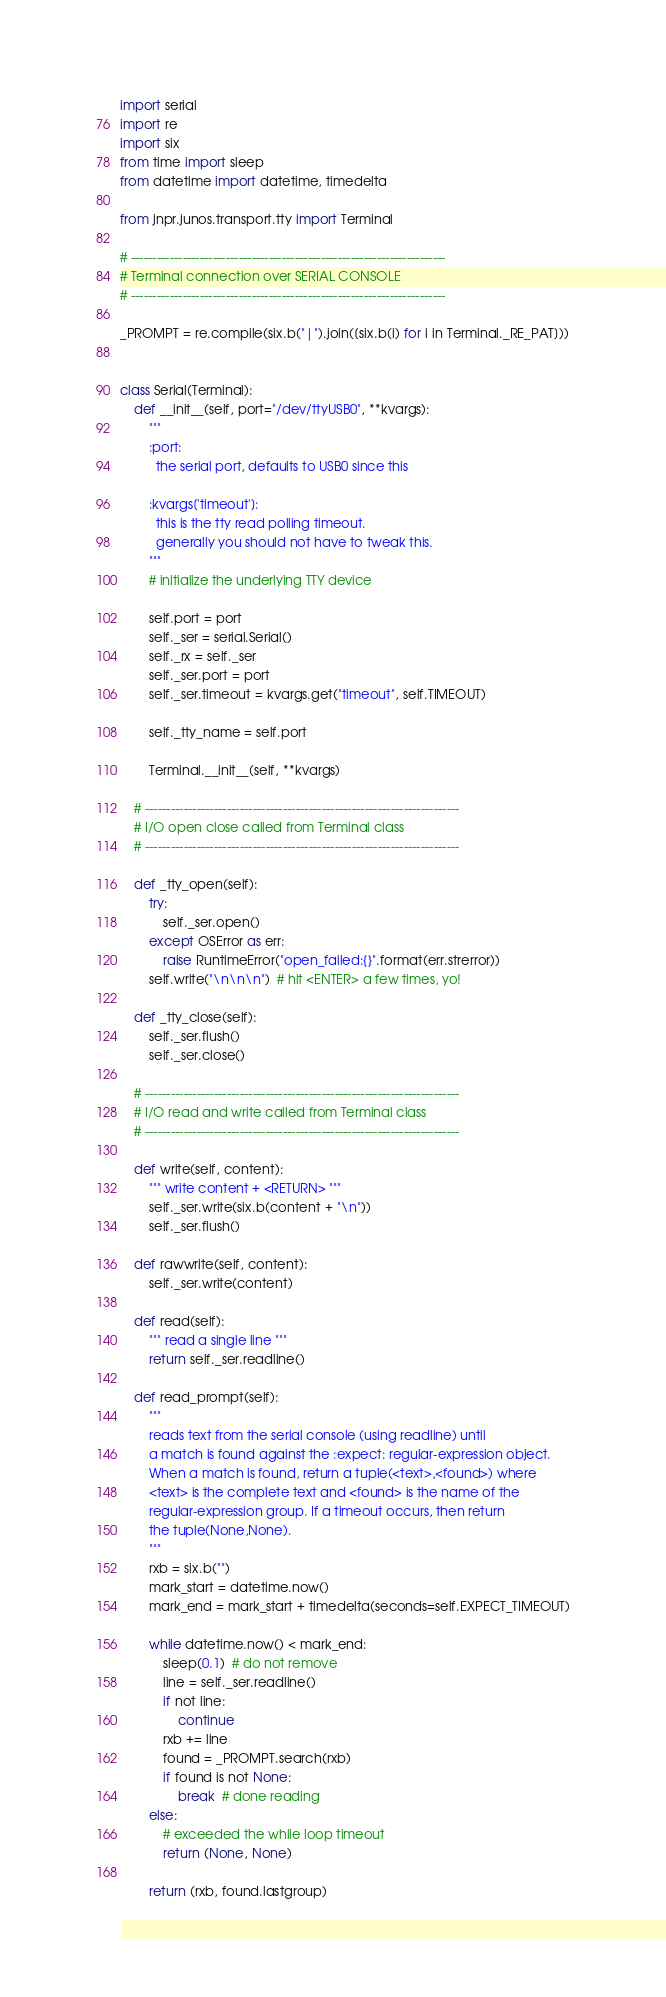Convert code to text. <code><loc_0><loc_0><loc_500><loc_500><_Python_>import serial
import re
import six
from time import sleep
from datetime import datetime, timedelta

from jnpr.junos.transport.tty import Terminal

# -------------------------------------------------------------------------
# Terminal connection over SERIAL CONSOLE
# -------------------------------------------------------------------------

_PROMPT = re.compile(six.b("|").join([six.b(i) for i in Terminal._RE_PAT]))


class Serial(Terminal):
    def __init__(self, port="/dev/ttyUSB0", **kvargs):
        """
        :port:
          the serial port, defaults to USB0 since this

        :kvargs['timeout']:
          this is the tty read polling timeout.
          generally you should not have to tweak this.
        """
        # initialize the underlying TTY device

        self.port = port
        self._ser = serial.Serial()
        self._rx = self._ser
        self._ser.port = port
        self._ser.timeout = kvargs.get("timeout", self.TIMEOUT)

        self._tty_name = self.port

        Terminal.__init__(self, **kvargs)

    # -------------------------------------------------------------------------
    # I/O open close called from Terminal class
    # -------------------------------------------------------------------------

    def _tty_open(self):
        try:
            self._ser.open()
        except OSError as err:
            raise RuntimeError("open_failed:{}".format(err.strerror))
        self.write("\n\n\n")  # hit <ENTER> a few times, yo!

    def _tty_close(self):
        self._ser.flush()
        self._ser.close()

    # -------------------------------------------------------------------------
    # I/O read and write called from Terminal class
    # -------------------------------------------------------------------------

    def write(self, content):
        """ write content + <RETURN> """
        self._ser.write(six.b(content + "\n"))
        self._ser.flush()

    def rawwrite(self, content):
        self._ser.write(content)

    def read(self):
        """ read a single line """
        return self._ser.readline()

    def read_prompt(self):
        """
        reads text from the serial console (using readline) until
        a match is found against the :expect: regular-expression object.
        When a match is found, return a tuple(<text>,<found>) where
        <text> is the complete text and <found> is the name of the
        regular-expression group. If a timeout occurs, then return
        the tuple(None,None).
        """
        rxb = six.b("")
        mark_start = datetime.now()
        mark_end = mark_start + timedelta(seconds=self.EXPECT_TIMEOUT)

        while datetime.now() < mark_end:
            sleep(0.1)  # do not remove
            line = self._ser.readline()
            if not line:
                continue
            rxb += line
            found = _PROMPT.search(rxb)
            if found is not None:
                break  # done reading
        else:
            # exceeded the while loop timeout
            return (None, None)

        return (rxb, found.lastgroup)
</code> 